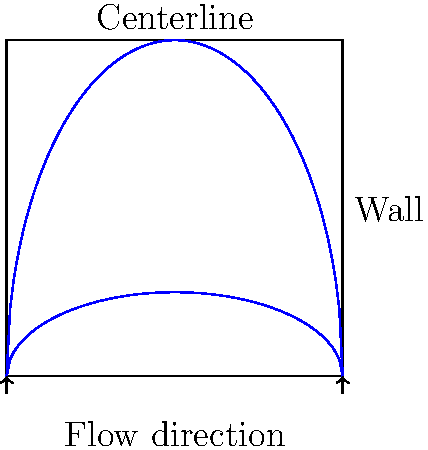In a fully developed laminar pipe flow, how does the velocity profile relate to the streamlines shown in the figure? Consider the implications for the flow's behavior near the wall and at the centerline. To answer this question, let's analyze the velocity profile in a fully developed laminar pipe flow:

1. Streamline shape: The streamlines in the figure are curved, with the curvature more pronounced near the centerline and flatter near the walls.

2. Velocity profile interpretation:
   a. The spacing between streamlines is inversely proportional to the velocity magnitude.
   b. Closer streamlines indicate higher velocity gradients.

3. Near the wall:
   a. Streamlines are flatter and more closely spaced.
   b. This indicates a steep velocity gradient (high shear stress) and slower flow velocities.
   c. The no-slip condition applies at the wall, where velocity is zero.

4. At the centerline:
   a. Streamlines are more curved and widely spaced.
   b. This suggests higher velocities and lower velocity gradients.
   c. The velocity reaches its maximum at the centerline due to symmetry.

5. Velocity profile shape:
   a. The overall profile forms a parabolic shape.
   b. This is consistent with the Hagen-Poiseuille equation for laminar pipe flow: $$v(r) = v_{max}(1 - \frac{r^2}{R^2})$$
   where $v(r)$ is the velocity at radius $r$, $v_{max}$ is the maximum velocity at the centerline, and $R$ is the pipe radius.

6. Developmental psychology perspective:
   a. The velocity profile's gradual change from wall to centerline mirrors adolescent stress adaptation.
   b. Just as flow develops from high-stress (near wall) to low-stress (centerline) regions, adolescents learn to manage stress through gradual exposure and coping skill development.
Answer: Parabolic velocity profile with maximum at centerline, zero at walls 